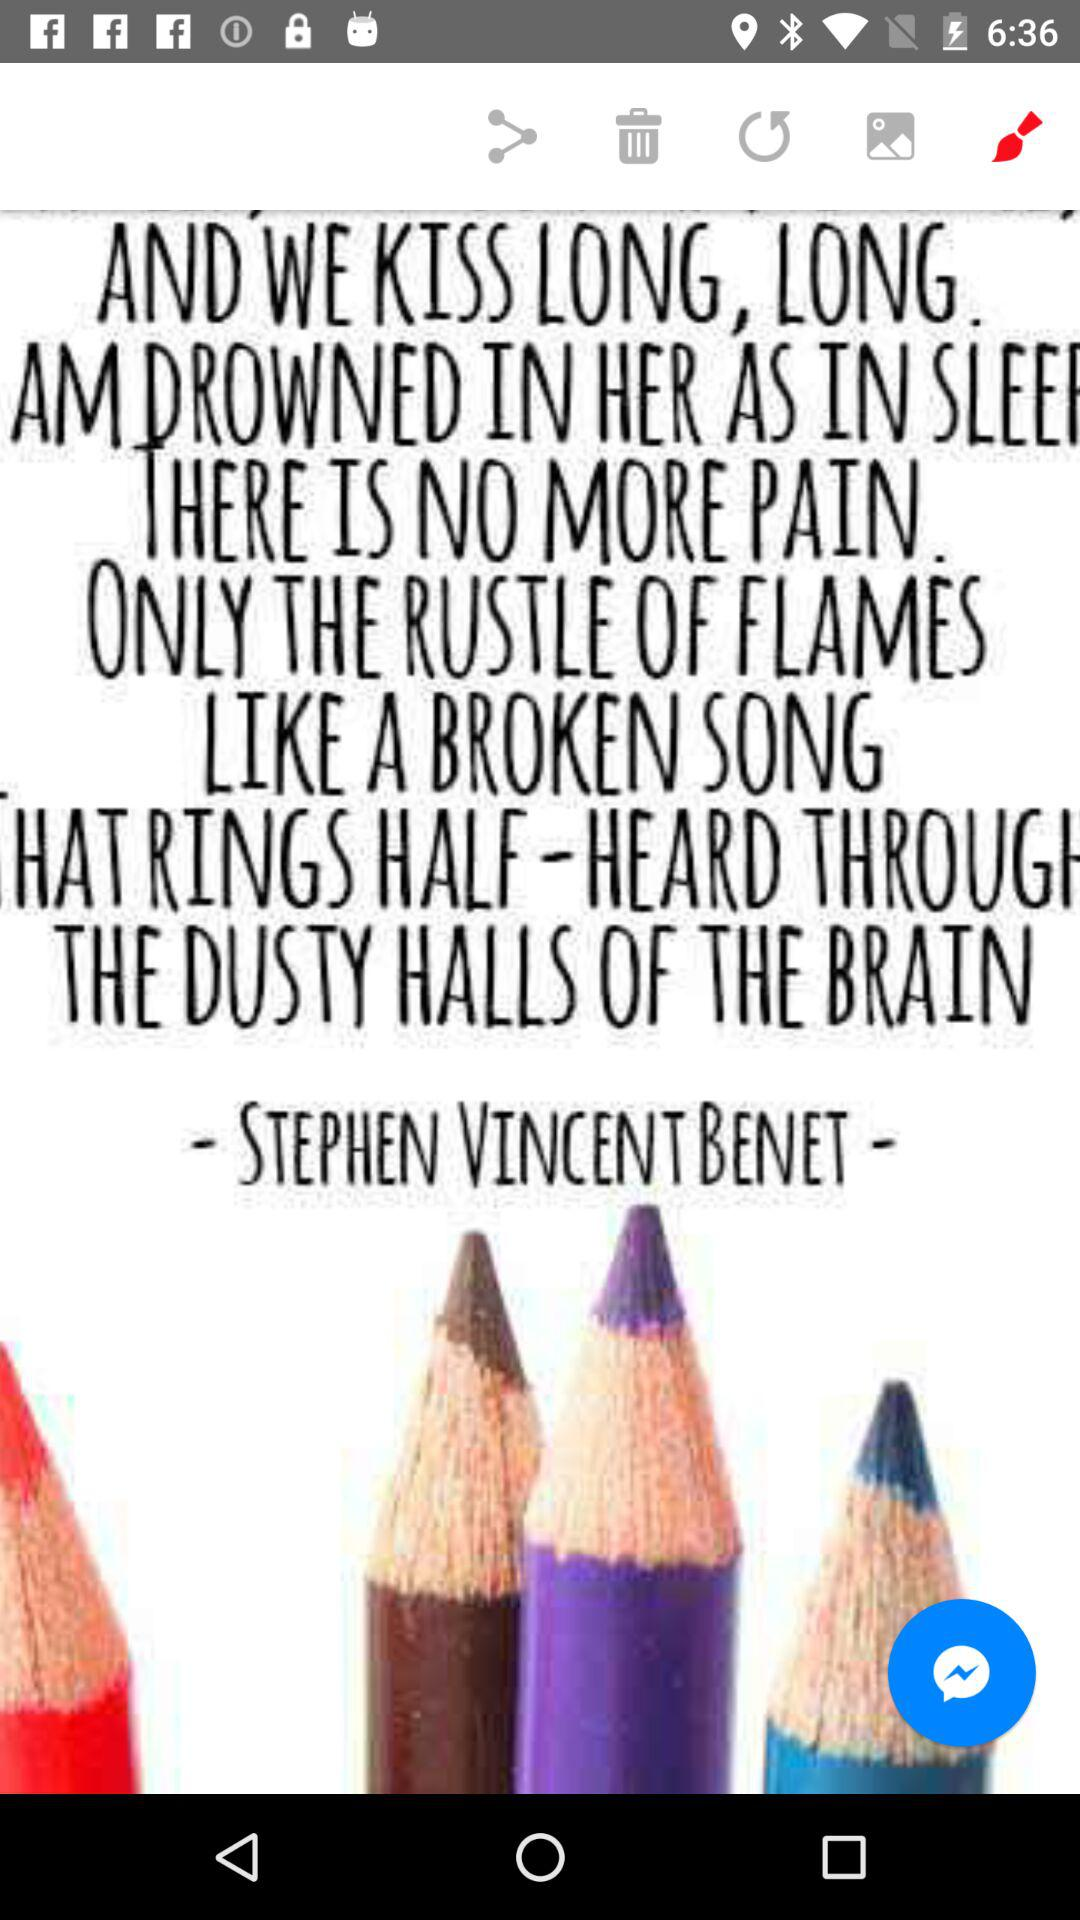What is the given sharing option? The given sharing option is "Messenger". 